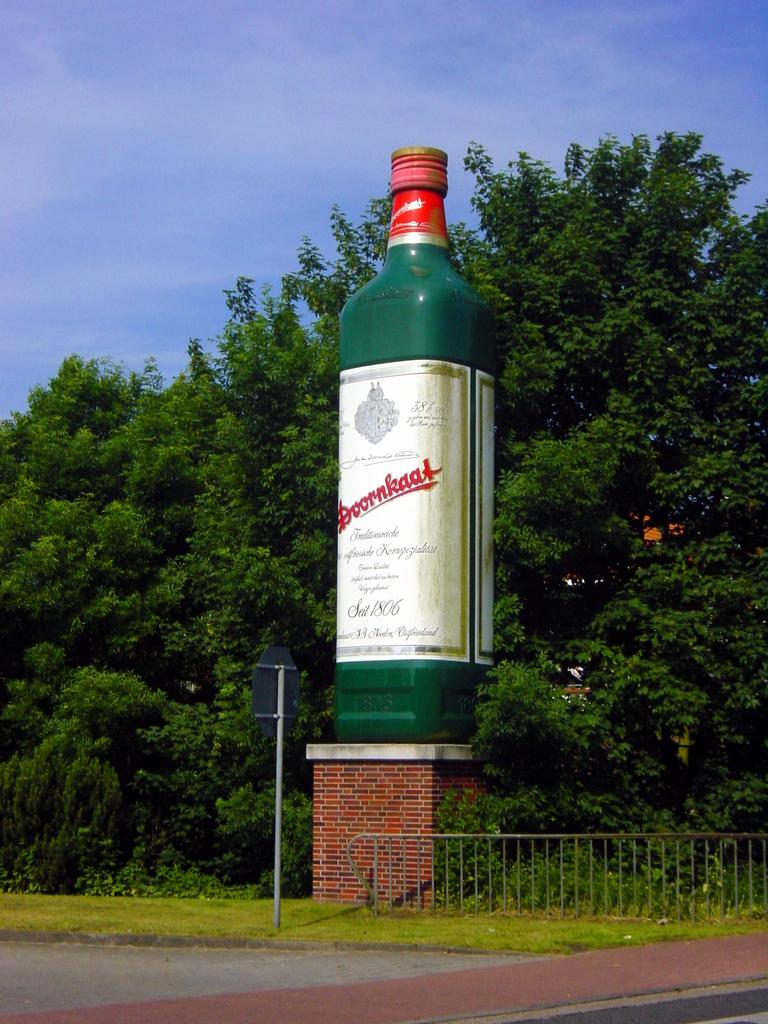Provide a one-sentence caption for the provided image. A big bottle of Doornkat scotch, outside and about as tall as the talles tree in the picture. 